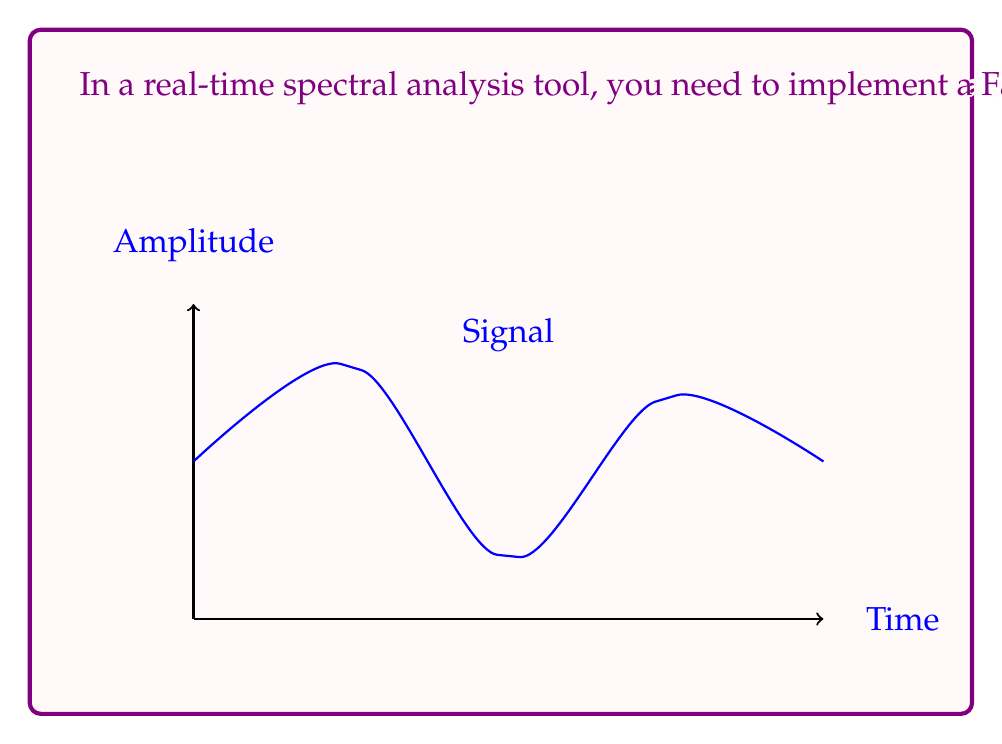Help me with this question. Let's approach this step-by-step:

1) The Cooley-Tukey radix-2 FFT algorithm works on input sizes that are powers of 2. Here, we have 1024 = $2^{10}$ samples.

2) The algorithm divides the problem into smaller FFTs recursively. At each stage, it performs $\frac{N}{2}$ butterfly operations, where N is the current size of the sub-problem.

3) Each butterfly operation requires 1 complex multiplication (twiddle factor is pre-computed) and 2 complex additions.

4) The number of stages in the FFT computation is $\log_2(N)$, where N is the total number of samples.

5) At each stage, we perform $\frac{N}{2}$ complex multiplications.

6) Therefore, the total number of complex multiplications is:

   $$\text{Total multiplications} = \frac{N}{2} \log_2(N)$$

7) Substituting N = 1024:

   $$\text{Total multiplications} = \frac{1024}{2} \log_2(1024) = 512 \times 10 = 5120$$

Thus, the minimum number of complex multiplications required is 5120.
Answer: 5120 